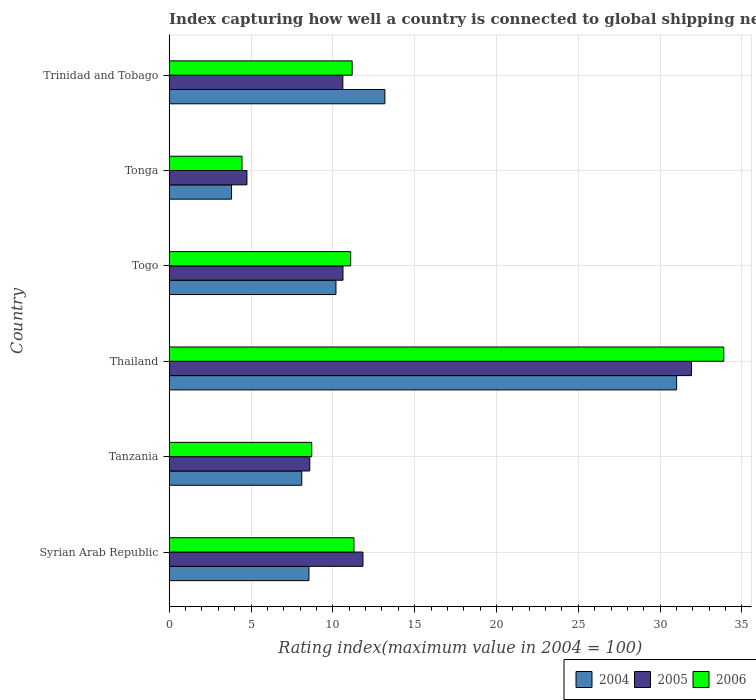How many groups of bars are there?
Offer a very short reply. 6. Are the number of bars on each tick of the Y-axis equal?
Your answer should be very brief. Yes. How many bars are there on the 6th tick from the bottom?
Give a very brief answer. 3. What is the label of the 1st group of bars from the top?
Your answer should be very brief. Trinidad and Tobago. In how many cases, is the number of bars for a given country not equal to the number of legend labels?
Offer a terse response. 0. What is the rating index in 2004 in Togo?
Provide a succinct answer. 10.19. Across all countries, what is the maximum rating index in 2005?
Offer a very short reply. 31.92. Across all countries, what is the minimum rating index in 2006?
Provide a succinct answer. 4.45. In which country was the rating index in 2004 maximum?
Give a very brief answer. Thailand. In which country was the rating index in 2004 minimum?
Provide a short and direct response. Tonga. What is the total rating index in 2006 in the graph?
Offer a terse response. 80.61. What is the difference between the rating index in 2006 in Togo and that in Trinidad and Tobago?
Ensure brevity in your answer.  -0.09. What is the average rating index in 2004 per country?
Make the answer very short. 12.47. What is the difference between the rating index in 2004 and rating index in 2006 in Togo?
Your response must be concise. -0.9. In how many countries, is the rating index in 2005 greater than 30 ?
Keep it short and to the point. 1. What is the ratio of the rating index in 2006 in Tanzania to that in Thailand?
Your response must be concise. 0.26. Is the rating index in 2006 in Togo less than that in Trinidad and Tobago?
Offer a very short reply. Yes. What is the difference between the highest and the second highest rating index in 2004?
Your answer should be compact. 17.83. What is the difference between the highest and the lowest rating index in 2004?
Provide a short and direct response. 27.2. What does the 3rd bar from the bottom in Togo represents?
Give a very brief answer. 2006. Is it the case that in every country, the sum of the rating index in 2006 and rating index in 2004 is greater than the rating index in 2005?
Ensure brevity in your answer.  Yes. How many bars are there?
Provide a short and direct response. 18. What is the difference between two consecutive major ticks on the X-axis?
Offer a very short reply. 5. Where does the legend appear in the graph?
Provide a short and direct response. Bottom right. How many legend labels are there?
Provide a short and direct response. 3. How are the legend labels stacked?
Provide a succinct answer. Horizontal. What is the title of the graph?
Provide a succinct answer. Index capturing how well a country is connected to global shipping networks. What is the label or title of the X-axis?
Your answer should be very brief. Rating index(maximum value in 2004 = 100). What is the label or title of the Y-axis?
Make the answer very short. Country. What is the Rating index(maximum value in 2004 = 100) of 2004 in Syrian Arab Republic?
Provide a succinct answer. 8.54. What is the Rating index(maximum value in 2004 = 100) of 2005 in Syrian Arab Republic?
Give a very brief answer. 11.84. What is the Rating index(maximum value in 2004 = 100) of 2006 in Syrian Arab Republic?
Your answer should be very brief. 11.29. What is the Rating index(maximum value in 2004 = 100) in 2005 in Tanzania?
Give a very brief answer. 8.59. What is the Rating index(maximum value in 2004 = 100) of 2006 in Tanzania?
Your answer should be compact. 8.71. What is the Rating index(maximum value in 2004 = 100) in 2004 in Thailand?
Your answer should be very brief. 31.01. What is the Rating index(maximum value in 2004 = 100) in 2005 in Thailand?
Your response must be concise. 31.92. What is the Rating index(maximum value in 2004 = 100) of 2006 in Thailand?
Your answer should be compact. 33.89. What is the Rating index(maximum value in 2004 = 100) of 2004 in Togo?
Provide a succinct answer. 10.19. What is the Rating index(maximum value in 2004 = 100) of 2005 in Togo?
Give a very brief answer. 10.62. What is the Rating index(maximum value in 2004 = 100) of 2006 in Togo?
Your answer should be compact. 11.09. What is the Rating index(maximum value in 2004 = 100) in 2004 in Tonga?
Keep it short and to the point. 3.81. What is the Rating index(maximum value in 2004 = 100) in 2005 in Tonga?
Ensure brevity in your answer.  4.75. What is the Rating index(maximum value in 2004 = 100) of 2006 in Tonga?
Keep it short and to the point. 4.45. What is the Rating index(maximum value in 2004 = 100) of 2004 in Trinidad and Tobago?
Your answer should be very brief. 13.18. What is the Rating index(maximum value in 2004 = 100) in 2005 in Trinidad and Tobago?
Provide a succinct answer. 10.61. What is the Rating index(maximum value in 2004 = 100) of 2006 in Trinidad and Tobago?
Offer a terse response. 11.18. Across all countries, what is the maximum Rating index(maximum value in 2004 = 100) of 2004?
Give a very brief answer. 31.01. Across all countries, what is the maximum Rating index(maximum value in 2004 = 100) of 2005?
Offer a very short reply. 31.92. Across all countries, what is the maximum Rating index(maximum value in 2004 = 100) in 2006?
Provide a short and direct response. 33.89. Across all countries, what is the minimum Rating index(maximum value in 2004 = 100) in 2004?
Provide a succinct answer. 3.81. Across all countries, what is the minimum Rating index(maximum value in 2004 = 100) in 2005?
Your response must be concise. 4.75. Across all countries, what is the minimum Rating index(maximum value in 2004 = 100) in 2006?
Your response must be concise. 4.45. What is the total Rating index(maximum value in 2004 = 100) of 2004 in the graph?
Keep it short and to the point. 74.83. What is the total Rating index(maximum value in 2004 = 100) in 2005 in the graph?
Provide a succinct answer. 78.33. What is the total Rating index(maximum value in 2004 = 100) of 2006 in the graph?
Provide a succinct answer. 80.61. What is the difference between the Rating index(maximum value in 2004 = 100) of 2004 in Syrian Arab Republic and that in Tanzania?
Your response must be concise. 0.44. What is the difference between the Rating index(maximum value in 2004 = 100) of 2005 in Syrian Arab Republic and that in Tanzania?
Your answer should be compact. 3.25. What is the difference between the Rating index(maximum value in 2004 = 100) in 2006 in Syrian Arab Republic and that in Tanzania?
Provide a succinct answer. 2.58. What is the difference between the Rating index(maximum value in 2004 = 100) of 2004 in Syrian Arab Republic and that in Thailand?
Your answer should be very brief. -22.47. What is the difference between the Rating index(maximum value in 2004 = 100) of 2005 in Syrian Arab Republic and that in Thailand?
Your response must be concise. -20.08. What is the difference between the Rating index(maximum value in 2004 = 100) of 2006 in Syrian Arab Republic and that in Thailand?
Your answer should be compact. -22.6. What is the difference between the Rating index(maximum value in 2004 = 100) in 2004 in Syrian Arab Republic and that in Togo?
Your answer should be very brief. -1.65. What is the difference between the Rating index(maximum value in 2004 = 100) in 2005 in Syrian Arab Republic and that in Togo?
Offer a terse response. 1.22. What is the difference between the Rating index(maximum value in 2004 = 100) of 2004 in Syrian Arab Republic and that in Tonga?
Your response must be concise. 4.73. What is the difference between the Rating index(maximum value in 2004 = 100) in 2005 in Syrian Arab Republic and that in Tonga?
Offer a very short reply. 7.09. What is the difference between the Rating index(maximum value in 2004 = 100) of 2006 in Syrian Arab Republic and that in Tonga?
Give a very brief answer. 6.84. What is the difference between the Rating index(maximum value in 2004 = 100) of 2004 in Syrian Arab Republic and that in Trinidad and Tobago?
Provide a short and direct response. -4.64. What is the difference between the Rating index(maximum value in 2004 = 100) in 2005 in Syrian Arab Republic and that in Trinidad and Tobago?
Keep it short and to the point. 1.23. What is the difference between the Rating index(maximum value in 2004 = 100) of 2006 in Syrian Arab Republic and that in Trinidad and Tobago?
Give a very brief answer. 0.11. What is the difference between the Rating index(maximum value in 2004 = 100) of 2004 in Tanzania and that in Thailand?
Provide a short and direct response. -22.91. What is the difference between the Rating index(maximum value in 2004 = 100) in 2005 in Tanzania and that in Thailand?
Your answer should be compact. -23.33. What is the difference between the Rating index(maximum value in 2004 = 100) in 2006 in Tanzania and that in Thailand?
Offer a very short reply. -25.18. What is the difference between the Rating index(maximum value in 2004 = 100) of 2004 in Tanzania and that in Togo?
Your answer should be compact. -2.09. What is the difference between the Rating index(maximum value in 2004 = 100) in 2005 in Tanzania and that in Togo?
Your answer should be compact. -2.03. What is the difference between the Rating index(maximum value in 2004 = 100) in 2006 in Tanzania and that in Togo?
Offer a very short reply. -2.38. What is the difference between the Rating index(maximum value in 2004 = 100) of 2004 in Tanzania and that in Tonga?
Offer a terse response. 4.29. What is the difference between the Rating index(maximum value in 2004 = 100) in 2005 in Tanzania and that in Tonga?
Your response must be concise. 3.84. What is the difference between the Rating index(maximum value in 2004 = 100) of 2006 in Tanzania and that in Tonga?
Your answer should be compact. 4.26. What is the difference between the Rating index(maximum value in 2004 = 100) of 2004 in Tanzania and that in Trinidad and Tobago?
Your answer should be compact. -5.08. What is the difference between the Rating index(maximum value in 2004 = 100) of 2005 in Tanzania and that in Trinidad and Tobago?
Your answer should be compact. -2.02. What is the difference between the Rating index(maximum value in 2004 = 100) in 2006 in Tanzania and that in Trinidad and Tobago?
Make the answer very short. -2.47. What is the difference between the Rating index(maximum value in 2004 = 100) in 2004 in Thailand and that in Togo?
Your answer should be very brief. 20.82. What is the difference between the Rating index(maximum value in 2004 = 100) in 2005 in Thailand and that in Togo?
Make the answer very short. 21.3. What is the difference between the Rating index(maximum value in 2004 = 100) of 2006 in Thailand and that in Togo?
Keep it short and to the point. 22.8. What is the difference between the Rating index(maximum value in 2004 = 100) in 2004 in Thailand and that in Tonga?
Give a very brief answer. 27.2. What is the difference between the Rating index(maximum value in 2004 = 100) in 2005 in Thailand and that in Tonga?
Make the answer very short. 27.17. What is the difference between the Rating index(maximum value in 2004 = 100) in 2006 in Thailand and that in Tonga?
Your answer should be compact. 29.44. What is the difference between the Rating index(maximum value in 2004 = 100) of 2004 in Thailand and that in Trinidad and Tobago?
Keep it short and to the point. 17.83. What is the difference between the Rating index(maximum value in 2004 = 100) in 2005 in Thailand and that in Trinidad and Tobago?
Provide a short and direct response. 21.31. What is the difference between the Rating index(maximum value in 2004 = 100) of 2006 in Thailand and that in Trinidad and Tobago?
Provide a succinct answer. 22.71. What is the difference between the Rating index(maximum value in 2004 = 100) in 2004 in Togo and that in Tonga?
Your answer should be compact. 6.38. What is the difference between the Rating index(maximum value in 2004 = 100) of 2005 in Togo and that in Tonga?
Provide a short and direct response. 5.87. What is the difference between the Rating index(maximum value in 2004 = 100) in 2006 in Togo and that in Tonga?
Your answer should be compact. 6.64. What is the difference between the Rating index(maximum value in 2004 = 100) of 2004 in Togo and that in Trinidad and Tobago?
Offer a very short reply. -2.99. What is the difference between the Rating index(maximum value in 2004 = 100) of 2006 in Togo and that in Trinidad and Tobago?
Your answer should be very brief. -0.09. What is the difference between the Rating index(maximum value in 2004 = 100) in 2004 in Tonga and that in Trinidad and Tobago?
Your response must be concise. -9.37. What is the difference between the Rating index(maximum value in 2004 = 100) of 2005 in Tonga and that in Trinidad and Tobago?
Offer a terse response. -5.86. What is the difference between the Rating index(maximum value in 2004 = 100) of 2006 in Tonga and that in Trinidad and Tobago?
Provide a short and direct response. -6.73. What is the difference between the Rating index(maximum value in 2004 = 100) of 2004 in Syrian Arab Republic and the Rating index(maximum value in 2004 = 100) of 2006 in Tanzania?
Your response must be concise. -0.17. What is the difference between the Rating index(maximum value in 2004 = 100) in 2005 in Syrian Arab Republic and the Rating index(maximum value in 2004 = 100) in 2006 in Tanzania?
Give a very brief answer. 3.13. What is the difference between the Rating index(maximum value in 2004 = 100) in 2004 in Syrian Arab Republic and the Rating index(maximum value in 2004 = 100) in 2005 in Thailand?
Your answer should be compact. -23.38. What is the difference between the Rating index(maximum value in 2004 = 100) of 2004 in Syrian Arab Republic and the Rating index(maximum value in 2004 = 100) of 2006 in Thailand?
Offer a terse response. -25.35. What is the difference between the Rating index(maximum value in 2004 = 100) in 2005 in Syrian Arab Republic and the Rating index(maximum value in 2004 = 100) in 2006 in Thailand?
Make the answer very short. -22.05. What is the difference between the Rating index(maximum value in 2004 = 100) in 2004 in Syrian Arab Republic and the Rating index(maximum value in 2004 = 100) in 2005 in Togo?
Give a very brief answer. -2.08. What is the difference between the Rating index(maximum value in 2004 = 100) in 2004 in Syrian Arab Republic and the Rating index(maximum value in 2004 = 100) in 2006 in Togo?
Keep it short and to the point. -2.55. What is the difference between the Rating index(maximum value in 2004 = 100) in 2004 in Syrian Arab Republic and the Rating index(maximum value in 2004 = 100) in 2005 in Tonga?
Your response must be concise. 3.79. What is the difference between the Rating index(maximum value in 2004 = 100) of 2004 in Syrian Arab Republic and the Rating index(maximum value in 2004 = 100) of 2006 in Tonga?
Ensure brevity in your answer.  4.09. What is the difference between the Rating index(maximum value in 2004 = 100) of 2005 in Syrian Arab Republic and the Rating index(maximum value in 2004 = 100) of 2006 in Tonga?
Your response must be concise. 7.39. What is the difference between the Rating index(maximum value in 2004 = 100) in 2004 in Syrian Arab Republic and the Rating index(maximum value in 2004 = 100) in 2005 in Trinidad and Tobago?
Provide a short and direct response. -2.07. What is the difference between the Rating index(maximum value in 2004 = 100) of 2004 in Syrian Arab Republic and the Rating index(maximum value in 2004 = 100) of 2006 in Trinidad and Tobago?
Your answer should be compact. -2.64. What is the difference between the Rating index(maximum value in 2004 = 100) of 2005 in Syrian Arab Republic and the Rating index(maximum value in 2004 = 100) of 2006 in Trinidad and Tobago?
Your response must be concise. 0.66. What is the difference between the Rating index(maximum value in 2004 = 100) in 2004 in Tanzania and the Rating index(maximum value in 2004 = 100) in 2005 in Thailand?
Offer a terse response. -23.82. What is the difference between the Rating index(maximum value in 2004 = 100) in 2004 in Tanzania and the Rating index(maximum value in 2004 = 100) in 2006 in Thailand?
Provide a succinct answer. -25.79. What is the difference between the Rating index(maximum value in 2004 = 100) of 2005 in Tanzania and the Rating index(maximum value in 2004 = 100) of 2006 in Thailand?
Offer a very short reply. -25.3. What is the difference between the Rating index(maximum value in 2004 = 100) of 2004 in Tanzania and the Rating index(maximum value in 2004 = 100) of 2005 in Togo?
Offer a very short reply. -2.52. What is the difference between the Rating index(maximum value in 2004 = 100) of 2004 in Tanzania and the Rating index(maximum value in 2004 = 100) of 2006 in Togo?
Keep it short and to the point. -2.99. What is the difference between the Rating index(maximum value in 2004 = 100) of 2004 in Tanzania and the Rating index(maximum value in 2004 = 100) of 2005 in Tonga?
Ensure brevity in your answer.  3.35. What is the difference between the Rating index(maximum value in 2004 = 100) of 2004 in Tanzania and the Rating index(maximum value in 2004 = 100) of 2006 in Tonga?
Keep it short and to the point. 3.65. What is the difference between the Rating index(maximum value in 2004 = 100) in 2005 in Tanzania and the Rating index(maximum value in 2004 = 100) in 2006 in Tonga?
Provide a short and direct response. 4.14. What is the difference between the Rating index(maximum value in 2004 = 100) of 2004 in Tanzania and the Rating index(maximum value in 2004 = 100) of 2005 in Trinidad and Tobago?
Your answer should be very brief. -2.51. What is the difference between the Rating index(maximum value in 2004 = 100) in 2004 in Tanzania and the Rating index(maximum value in 2004 = 100) in 2006 in Trinidad and Tobago?
Give a very brief answer. -3.08. What is the difference between the Rating index(maximum value in 2004 = 100) in 2005 in Tanzania and the Rating index(maximum value in 2004 = 100) in 2006 in Trinidad and Tobago?
Offer a very short reply. -2.59. What is the difference between the Rating index(maximum value in 2004 = 100) in 2004 in Thailand and the Rating index(maximum value in 2004 = 100) in 2005 in Togo?
Your response must be concise. 20.39. What is the difference between the Rating index(maximum value in 2004 = 100) in 2004 in Thailand and the Rating index(maximum value in 2004 = 100) in 2006 in Togo?
Your answer should be compact. 19.92. What is the difference between the Rating index(maximum value in 2004 = 100) in 2005 in Thailand and the Rating index(maximum value in 2004 = 100) in 2006 in Togo?
Your response must be concise. 20.83. What is the difference between the Rating index(maximum value in 2004 = 100) in 2004 in Thailand and the Rating index(maximum value in 2004 = 100) in 2005 in Tonga?
Ensure brevity in your answer.  26.26. What is the difference between the Rating index(maximum value in 2004 = 100) in 2004 in Thailand and the Rating index(maximum value in 2004 = 100) in 2006 in Tonga?
Make the answer very short. 26.56. What is the difference between the Rating index(maximum value in 2004 = 100) in 2005 in Thailand and the Rating index(maximum value in 2004 = 100) in 2006 in Tonga?
Give a very brief answer. 27.47. What is the difference between the Rating index(maximum value in 2004 = 100) of 2004 in Thailand and the Rating index(maximum value in 2004 = 100) of 2005 in Trinidad and Tobago?
Ensure brevity in your answer.  20.4. What is the difference between the Rating index(maximum value in 2004 = 100) in 2004 in Thailand and the Rating index(maximum value in 2004 = 100) in 2006 in Trinidad and Tobago?
Give a very brief answer. 19.83. What is the difference between the Rating index(maximum value in 2004 = 100) in 2005 in Thailand and the Rating index(maximum value in 2004 = 100) in 2006 in Trinidad and Tobago?
Your answer should be compact. 20.74. What is the difference between the Rating index(maximum value in 2004 = 100) of 2004 in Togo and the Rating index(maximum value in 2004 = 100) of 2005 in Tonga?
Your response must be concise. 5.44. What is the difference between the Rating index(maximum value in 2004 = 100) of 2004 in Togo and the Rating index(maximum value in 2004 = 100) of 2006 in Tonga?
Keep it short and to the point. 5.74. What is the difference between the Rating index(maximum value in 2004 = 100) in 2005 in Togo and the Rating index(maximum value in 2004 = 100) in 2006 in Tonga?
Offer a terse response. 6.17. What is the difference between the Rating index(maximum value in 2004 = 100) of 2004 in Togo and the Rating index(maximum value in 2004 = 100) of 2005 in Trinidad and Tobago?
Provide a succinct answer. -0.42. What is the difference between the Rating index(maximum value in 2004 = 100) of 2004 in Togo and the Rating index(maximum value in 2004 = 100) of 2006 in Trinidad and Tobago?
Make the answer very short. -0.99. What is the difference between the Rating index(maximum value in 2004 = 100) of 2005 in Togo and the Rating index(maximum value in 2004 = 100) of 2006 in Trinidad and Tobago?
Ensure brevity in your answer.  -0.56. What is the difference between the Rating index(maximum value in 2004 = 100) of 2004 in Tonga and the Rating index(maximum value in 2004 = 100) of 2005 in Trinidad and Tobago?
Your answer should be very brief. -6.8. What is the difference between the Rating index(maximum value in 2004 = 100) in 2004 in Tonga and the Rating index(maximum value in 2004 = 100) in 2006 in Trinidad and Tobago?
Offer a terse response. -7.37. What is the difference between the Rating index(maximum value in 2004 = 100) of 2005 in Tonga and the Rating index(maximum value in 2004 = 100) of 2006 in Trinidad and Tobago?
Give a very brief answer. -6.43. What is the average Rating index(maximum value in 2004 = 100) of 2004 per country?
Your answer should be compact. 12.47. What is the average Rating index(maximum value in 2004 = 100) of 2005 per country?
Your answer should be very brief. 13.05. What is the average Rating index(maximum value in 2004 = 100) in 2006 per country?
Your answer should be very brief. 13.44. What is the difference between the Rating index(maximum value in 2004 = 100) in 2004 and Rating index(maximum value in 2004 = 100) in 2006 in Syrian Arab Republic?
Keep it short and to the point. -2.75. What is the difference between the Rating index(maximum value in 2004 = 100) of 2005 and Rating index(maximum value in 2004 = 100) of 2006 in Syrian Arab Republic?
Ensure brevity in your answer.  0.55. What is the difference between the Rating index(maximum value in 2004 = 100) in 2004 and Rating index(maximum value in 2004 = 100) in 2005 in Tanzania?
Provide a short and direct response. -0.49. What is the difference between the Rating index(maximum value in 2004 = 100) of 2004 and Rating index(maximum value in 2004 = 100) of 2006 in Tanzania?
Offer a very short reply. -0.61. What is the difference between the Rating index(maximum value in 2004 = 100) in 2005 and Rating index(maximum value in 2004 = 100) in 2006 in Tanzania?
Provide a short and direct response. -0.12. What is the difference between the Rating index(maximum value in 2004 = 100) in 2004 and Rating index(maximum value in 2004 = 100) in 2005 in Thailand?
Provide a short and direct response. -0.91. What is the difference between the Rating index(maximum value in 2004 = 100) in 2004 and Rating index(maximum value in 2004 = 100) in 2006 in Thailand?
Offer a terse response. -2.88. What is the difference between the Rating index(maximum value in 2004 = 100) in 2005 and Rating index(maximum value in 2004 = 100) in 2006 in Thailand?
Your answer should be compact. -1.97. What is the difference between the Rating index(maximum value in 2004 = 100) in 2004 and Rating index(maximum value in 2004 = 100) in 2005 in Togo?
Provide a succinct answer. -0.43. What is the difference between the Rating index(maximum value in 2004 = 100) in 2005 and Rating index(maximum value in 2004 = 100) in 2006 in Togo?
Your answer should be compact. -0.47. What is the difference between the Rating index(maximum value in 2004 = 100) in 2004 and Rating index(maximum value in 2004 = 100) in 2005 in Tonga?
Offer a terse response. -0.94. What is the difference between the Rating index(maximum value in 2004 = 100) in 2004 and Rating index(maximum value in 2004 = 100) in 2006 in Tonga?
Keep it short and to the point. -0.64. What is the difference between the Rating index(maximum value in 2004 = 100) of 2005 and Rating index(maximum value in 2004 = 100) of 2006 in Tonga?
Offer a very short reply. 0.3. What is the difference between the Rating index(maximum value in 2004 = 100) of 2004 and Rating index(maximum value in 2004 = 100) of 2005 in Trinidad and Tobago?
Keep it short and to the point. 2.57. What is the difference between the Rating index(maximum value in 2004 = 100) in 2005 and Rating index(maximum value in 2004 = 100) in 2006 in Trinidad and Tobago?
Offer a terse response. -0.57. What is the ratio of the Rating index(maximum value in 2004 = 100) in 2004 in Syrian Arab Republic to that in Tanzania?
Ensure brevity in your answer.  1.05. What is the ratio of the Rating index(maximum value in 2004 = 100) in 2005 in Syrian Arab Republic to that in Tanzania?
Your answer should be very brief. 1.38. What is the ratio of the Rating index(maximum value in 2004 = 100) of 2006 in Syrian Arab Republic to that in Tanzania?
Make the answer very short. 1.3. What is the ratio of the Rating index(maximum value in 2004 = 100) of 2004 in Syrian Arab Republic to that in Thailand?
Offer a very short reply. 0.28. What is the ratio of the Rating index(maximum value in 2004 = 100) in 2005 in Syrian Arab Republic to that in Thailand?
Give a very brief answer. 0.37. What is the ratio of the Rating index(maximum value in 2004 = 100) in 2006 in Syrian Arab Republic to that in Thailand?
Keep it short and to the point. 0.33. What is the ratio of the Rating index(maximum value in 2004 = 100) of 2004 in Syrian Arab Republic to that in Togo?
Ensure brevity in your answer.  0.84. What is the ratio of the Rating index(maximum value in 2004 = 100) in 2005 in Syrian Arab Republic to that in Togo?
Your response must be concise. 1.11. What is the ratio of the Rating index(maximum value in 2004 = 100) in 2004 in Syrian Arab Republic to that in Tonga?
Keep it short and to the point. 2.24. What is the ratio of the Rating index(maximum value in 2004 = 100) in 2005 in Syrian Arab Republic to that in Tonga?
Make the answer very short. 2.49. What is the ratio of the Rating index(maximum value in 2004 = 100) in 2006 in Syrian Arab Republic to that in Tonga?
Give a very brief answer. 2.54. What is the ratio of the Rating index(maximum value in 2004 = 100) in 2004 in Syrian Arab Republic to that in Trinidad and Tobago?
Your answer should be very brief. 0.65. What is the ratio of the Rating index(maximum value in 2004 = 100) in 2005 in Syrian Arab Republic to that in Trinidad and Tobago?
Give a very brief answer. 1.12. What is the ratio of the Rating index(maximum value in 2004 = 100) in 2006 in Syrian Arab Republic to that in Trinidad and Tobago?
Ensure brevity in your answer.  1.01. What is the ratio of the Rating index(maximum value in 2004 = 100) of 2004 in Tanzania to that in Thailand?
Offer a terse response. 0.26. What is the ratio of the Rating index(maximum value in 2004 = 100) in 2005 in Tanzania to that in Thailand?
Offer a terse response. 0.27. What is the ratio of the Rating index(maximum value in 2004 = 100) of 2006 in Tanzania to that in Thailand?
Your response must be concise. 0.26. What is the ratio of the Rating index(maximum value in 2004 = 100) in 2004 in Tanzania to that in Togo?
Your response must be concise. 0.79. What is the ratio of the Rating index(maximum value in 2004 = 100) of 2005 in Tanzania to that in Togo?
Offer a very short reply. 0.81. What is the ratio of the Rating index(maximum value in 2004 = 100) of 2006 in Tanzania to that in Togo?
Your answer should be very brief. 0.79. What is the ratio of the Rating index(maximum value in 2004 = 100) in 2004 in Tanzania to that in Tonga?
Offer a very short reply. 2.13. What is the ratio of the Rating index(maximum value in 2004 = 100) of 2005 in Tanzania to that in Tonga?
Your answer should be very brief. 1.81. What is the ratio of the Rating index(maximum value in 2004 = 100) of 2006 in Tanzania to that in Tonga?
Provide a succinct answer. 1.96. What is the ratio of the Rating index(maximum value in 2004 = 100) of 2004 in Tanzania to that in Trinidad and Tobago?
Your answer should be compact. 0.61. What is the ratio of the Rating index(maximum value in 2004 = 100) of 2005 in Tanzania to that in Trinidad and Tobago?
Ensure brevity in your answer.  0.81. What is the ratio of the Rating index(maximum value in 2004 = 100) of 2006 in Tanzania to that in Trinidad and Tobago?
Provide a succinct answer. 0.78. What is the ratio of the Rating index(maximum value in 2004 = 100) in 2004 in Thailand to that in Togo?
Your answer should be compact. 3.04. What is the ratio of the Rating index(maximum value in 2004 = 100) of 2005 in Thailand to that in Togo?
Provide a succinct answer. 3.01. What is the ratio of the Rating index(maximum value in 2004 = 100) of 2006 in Thailand to that in Togo?
Give a very brief answer. 3.06. What is the ratio of the Rating index(maximum value in 2004 = 100) of 2004 in Thailand to that in Tonga?
Provide a succinct answer. 8.14. What is the ratio of the Rating index(maximum value in 2004 = 100) in 2005 in Thailand to that in Tonga?
Make the answer very short. 6.72. What is the ratio of the Rating index(maximum value in 2004 = 100) of 2006 in Thailand to that in Tonga?
Your answer should be very brief. 7.62. What is the ratio of the Rating index(maximum value in 2004 = 100) of 2004 in Thailand to that in Trinidad and Tobago?
Make the answer very short. 2.35. What is the ratio of the Rating index(maximum value in 2004 = 100) in 2005 in Thailand to that in Trinidad and Tobago?
Provide a succinct answer. 3.01. What is the ratio of the Rating index(maximum value in 2004 = 100) of 2006 in Thailand to that in Trinidad and Tobago?
Provide a succinct answer. 3.03. What is the ratio of the Rating index(maximum value in 2004 = 100) in 2004 in Togo to that in Tonga?
Make the answer very short. 2.67. What is the ratio of the Rating index(maximum value in 2004 = 100) of 2005 in Togo to that in Tonga?
Your response must be concise. 2.24. What is the ratio of the Rating index(maximum value in 2004 = 100) of 2006 in Togo to that in Tonga?
Provide a short and direct response. 2.49. What is the ratio of the Rating index(maximum value in 2004 = 100) in 2004 in Togo to that in Trinidad and Tobago?
Keep it short and to the point. 0.77. What is the ratio of the Rating index(maximum value in 2004 = 100) of 2004 in Tonga to that in Trinidad and Tobago?
Make the answer very short. 0.29. What is the ratio of the Rating index(maximum value in 2004 = 100) in 2005 in Tonga to that in Trinidad and Tobago?
Provide a succinct answer. 0.45. What is the ratio of the Rating index(maximum value in 2004 = 100) of 2006 in Tonga to that in Trinidad and Tobago?
Your response must be concise. 0.4. What is the difference between the highest and the second highest Rating index(maximum value in 2004 = 100) of 2004?
Offer a terse response. 17.83. What is the difference between the highest and the second highest Rating index(maximum value in 2004 = 100) in 2005?
Keep it short and to the point. 20.08. What is the difference between the highest and the second highest Rating index(maximum value in 2004 = 100) of 2006?
Give a very brief answer. 22.6. What is the difference between the highest and the lowest Rating index(maximum value in 2004 = 100) in 2004?
Your answer should be compact. 27.2. What is the difference between the highest and the lowest Rating index(maximum value in 2004 = 100) in 2005?
Your response must be concise. 27.17. What is the difference between the highest and the lowest Rating index(maximum value in 2004 = 100) of 2006?
Your response must be concise. 29.44. 